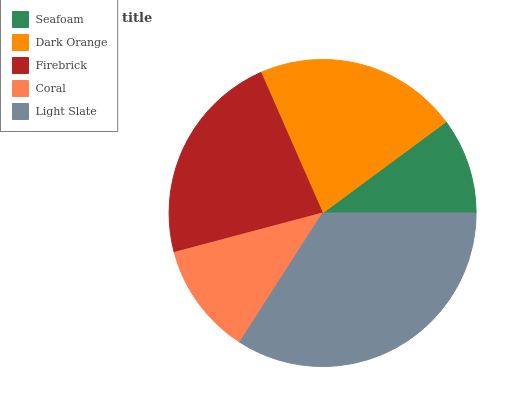Is Seafoam the minimum?
Answer yes or no. Yes. Is Light Slate the maximum?
Answer yes or no. Yes. Is Dark Orange the minimum?
Answer yes or no. No. Is Dark Orange the maximum?
Answer yes or no. No. Is Dark Orange greater than Seafoam?
Answer yes or no. Yes. Is Seafoam less than Dark Orange?
Answer yes or no. Yes. Is Seafoam greater than Dark Orange?
Answer yes or no. No. Is Dark Orange less than Seafoam?
Answer yes or no. No. Is Dark Orange the high median?
Answer yes or no. Yes. Is Dark Orange the low median?
Answer yes or no. Yes. Is Seafoam the high median?
Answer yes or no. No. Is Firebrick the low median?
Answer yes or no. No. 